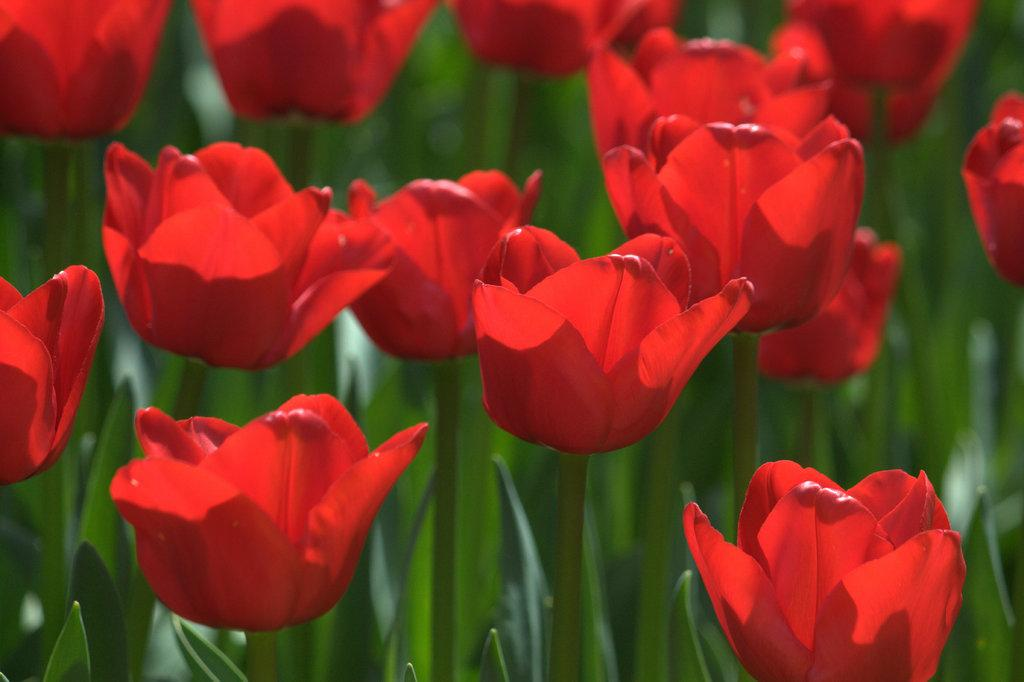What type of flowers are in the image? There are tulip flowers in the image. What color are the tulip flowers? The tulip flowers are red in color. Are there any spiders visible on the tulip flowers in the image? There is no mention of spiders in the provided facts, and therefore we cannot determine if any are present in the image. 